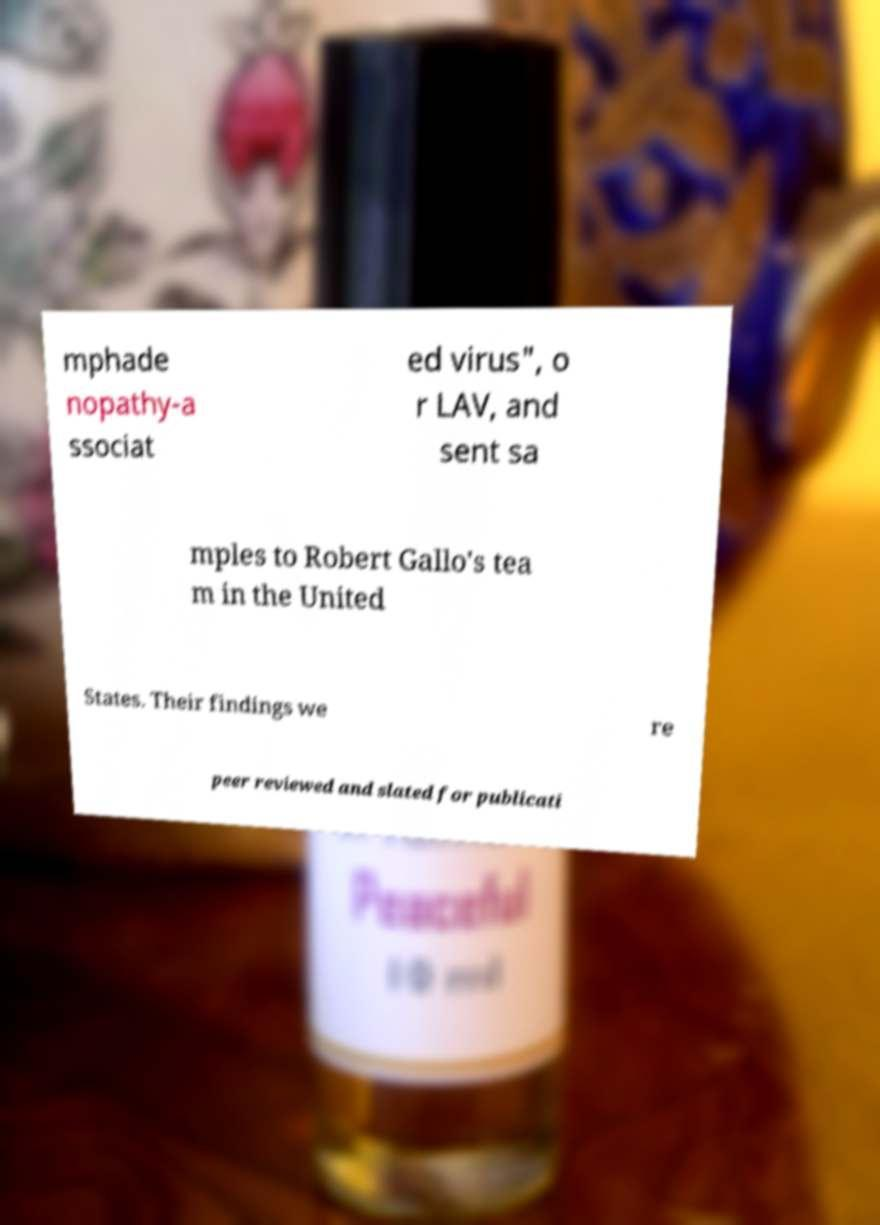Please identify and transcribe the text found in this image. mphade nopathy-a ssociat ed virus", o r LAV, and sent sa mples to Robert Gallo's tea m in the United States. Their findings we re peer reviewed and slated for publicati 